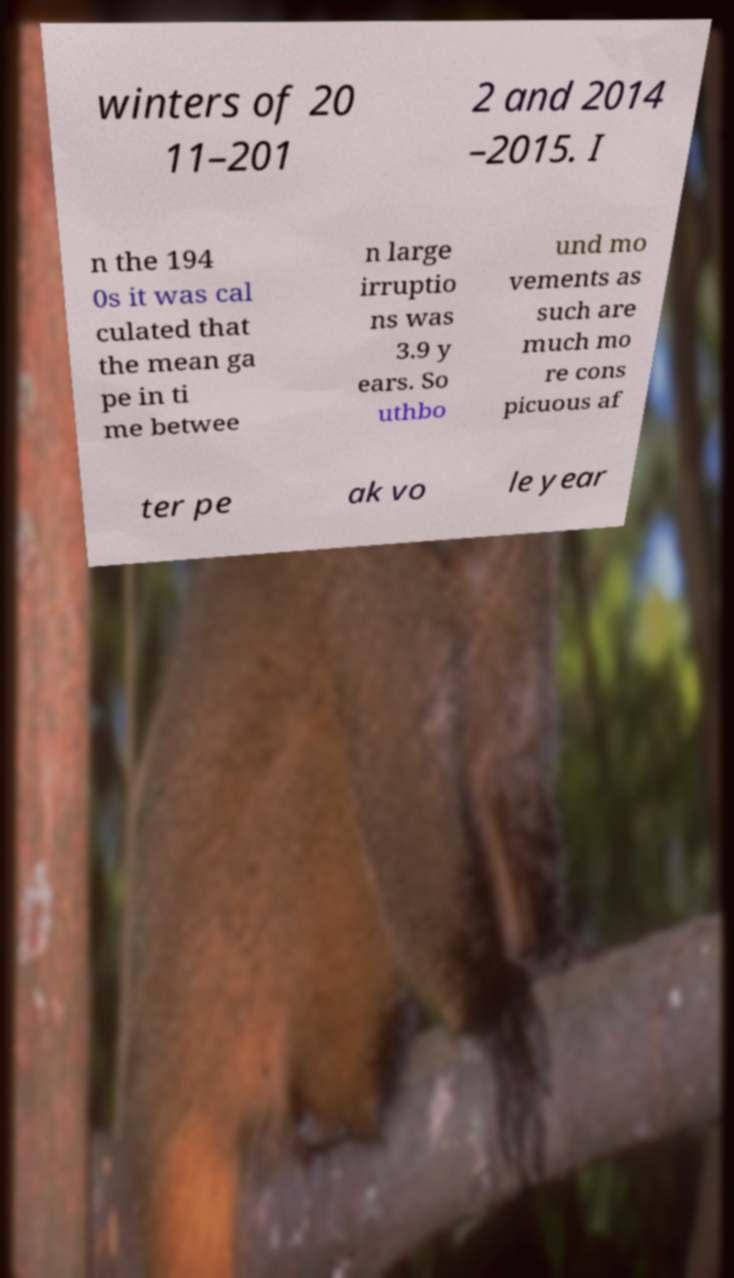What messages or text are displayed in this image? I need them in a readable, typed format. winters of 20 11–201 2 and 2014 –2015. I n the 194 0s it was cal culated that the mean ga pe in ti me betwee n large irruptio ns was 3.9 y ears. So uthbo und mo vements as such are much mo re cons picuous af ter pe ak vo le year 